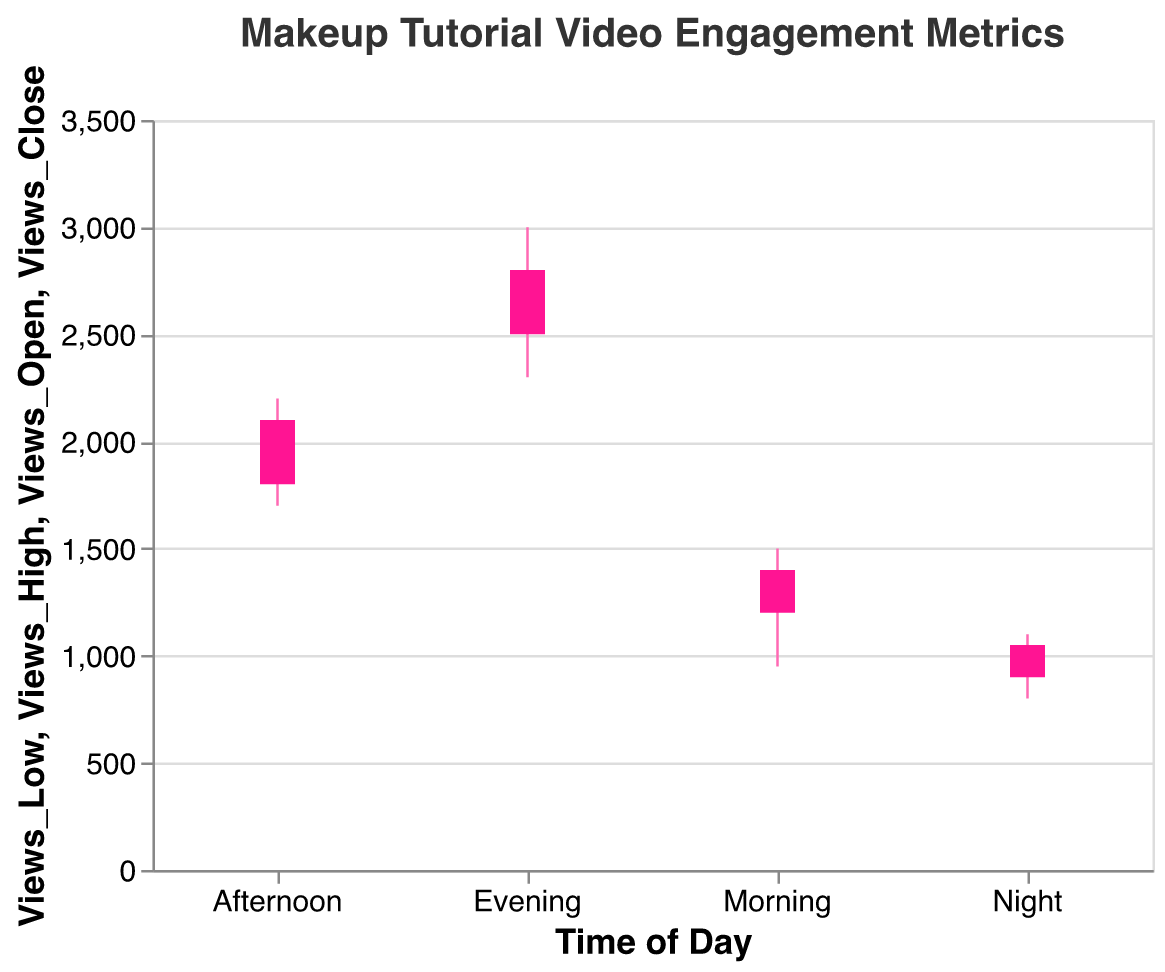What is the title of the plot? The title of the plot appears at the top and reads "Makeup Tutorial Video Engagement Metrics".
Answer: Makeup Tutorial Video Engagement Metrics What time of day has the highest peak in views? By looking at the highest points of the pink vertical bars, we can see that the Evening time has the highest peak in views at 3000.
Answer: Evening During what time of day do the likes have the lowest closing value? By examining the ending points of the darker pink bars representing the closing values of likes, we can see that Night has the lowest closing value of likes at 300.
Answer: Night How do the shares compare between Afternoon and Evening? By examining the ranges and closing points of shares for Afternoon and Evening, we see that Evening has both higher ranges (40 to 90) and higher closing values (80) compared to Afternoon (30 to 70, closing at 60).
Answer: Evening has higher shares What is the difference between the highest and lowest views in the Afternoon? The highest views in the Afternoon are 2200, and the lowest are 1700. The difference is 2200 - 1700 = 500.
Answer: 500 Which time of day shows an increase in views from opening to closing? We need to compare the opening and closing values of views: Morning (1200 to 1400), Afternoon (1800 to 2100), and Evening (2500 to 2800) all show an increase in views. Night (900 to 1050) also shows an increase.
Answer: All times show an increase What's the range of likes during the Morning? The range of likes in the Morning is calculated by subtracting the lowest value from the highest value: 450 - 250 = 200.
Answer: 200 What is the trend observed in shares from Morning to Night? By comparing the closing values of shares, we see an increase from Morning (40) to Afternoon (60), then to Evening (80), but a decrease at Night (20). So, the trend is increasing and then decreasing.
Answer: Increasing then decreasing Which metric shows the most significant change in value from opening to close in the Evening? The changes from opening to close in the Evening are: Views (2500 to 2800 = +300), Likes (700 to 800 = +100), Shares (50 to 80 = +30). Views show the most significant change.
Answer: Views How does the opening value of views vary across different times of the day? By comparing the opening views: Morning (1200), Afternoon (1800), Evening (2500), and Night (900), we see that Evening has the highest opening views, and Night has the lowest.
Answer: Evening has the highest; Night has the lowest 